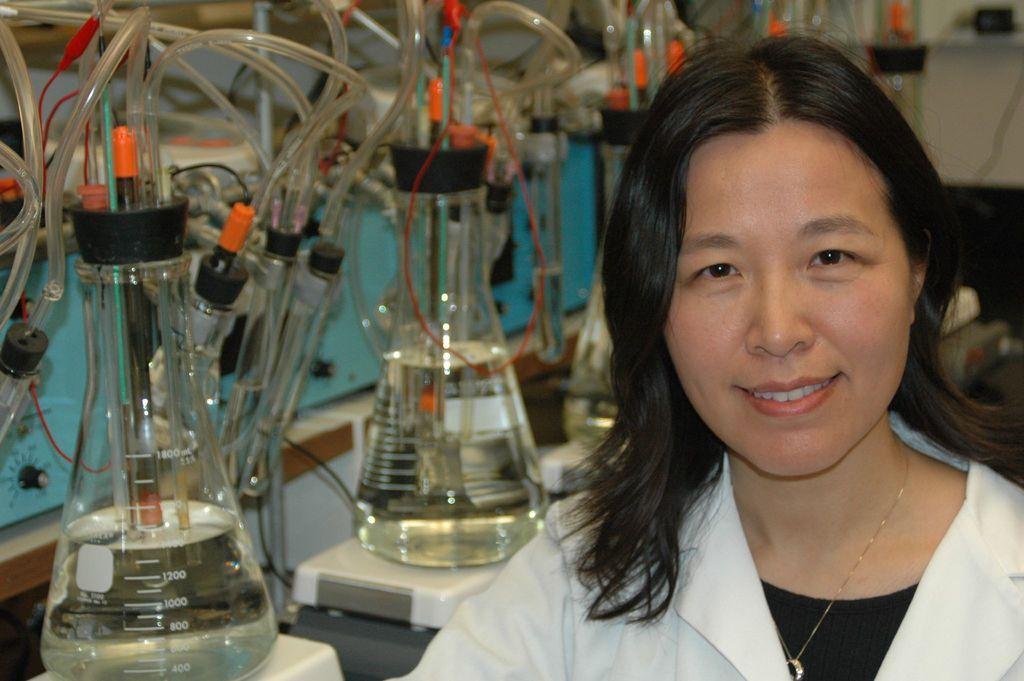Could you give a brief overview of what you see in this image? As we can see in the image on the right side there is a woman wearing white color jacket and there are glass flasks and pipes. 